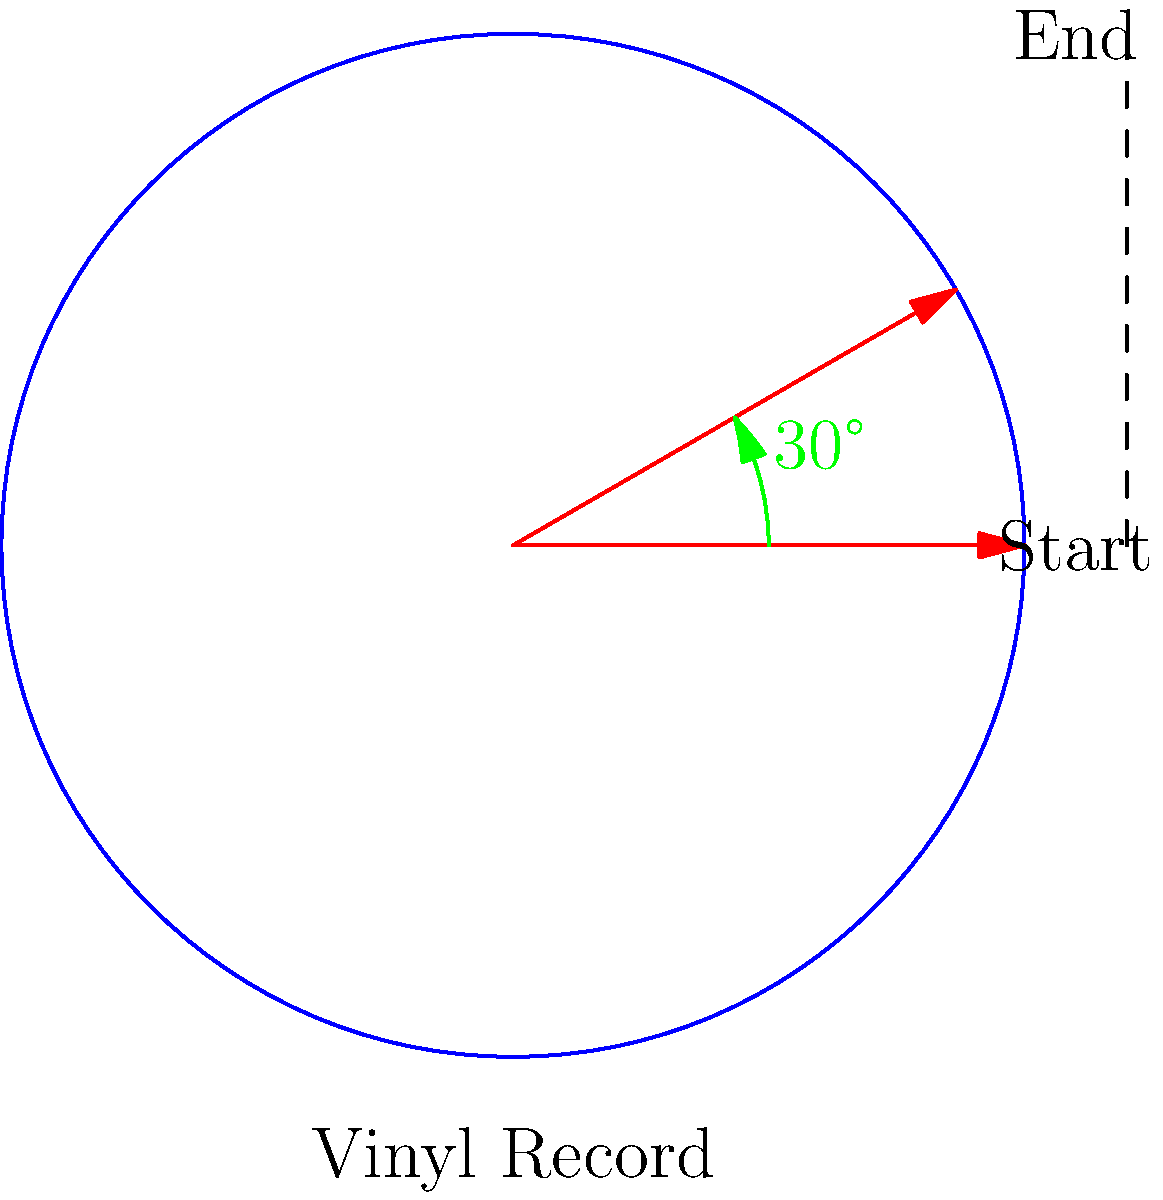Hey there, vinyl enthusiast! Imagine you're setting up your turntable to play your favorite Johnny Cash record. The needle starts at the outer edge and moves inward as it plays. If the record makes one complete rotation in 1.8 seconds, what's the angle (in degrees) that the record rotates through in 0.15 seconds? Alright, let's break this down step-by-step, just like lining up a perfect bank shot:

1) First, we need to understand the relationship between time and rotation:
   - Full rotation (360°) takes 1.8 seconds

2) We can set up a proportion:
   $\frac{360°}{1.8 \text{ seconds}} = \frac{x°}{0.15 \text{ seconds}}$

3) Cross multiply:
   $360 \cdot 0.15 = 1.8x$

4) Solve for $x$:
   $54 = 1.8x$
   $x = 54 \div 1.8 = 30$

5) Therefore, in 0.15 seconds, the record rotates through 30°.

This is just like in pool, where understanding angles is crucial. The precision in this calculation is similar to the precision needed in a well-executed shot!
Answer: 30° 